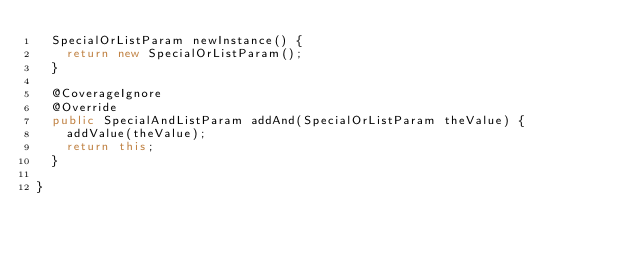<code> <loc_0><loc_0><loc_500><loc_500><_Java_>	SpecialOrListParam newInstance() {
		return new SpecialOrListParam();
	}
	
	@CoverageIgnore
	@Override
	public SpecialAndListParam addAnd(SpecialOrListParam theValue) {
		addValue(theValue);
		return this;
	}

}
</code> 